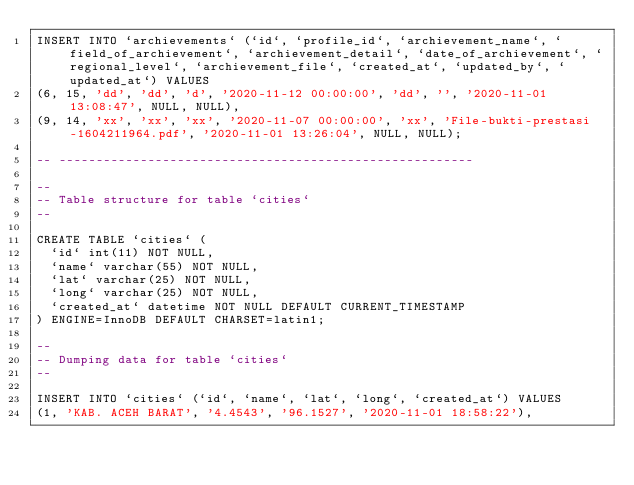Convert code to text. <code><loc_0><loc_0><loc_500><loc_500><_SQL_>INSERT INTO `archievements` (`id`, `profile_id`, `archievement_name`, `field_of_archievement`, `archievement_detail`, `date_of_archievement`, `regional_level`, `archievement_file`, `created_at`, `updated_by`, `updated_at`) VALUES
(6, 15, 'dd', 'dd', 'd', '2020-11-12 00:00:00', 'dd', '', '2020-11-01 13:08:47', NULL, NULL),
(9, 14, 'xx', 'xx', 'xx', '2020-11-07 00:00:00', 'xx', 'File-bukti-prestasi-1604211964.pdf', '2020-11-01 13:26:04', NULL, NULL);

-- --------------------------------------------------------

--
-- Table structure for table `cities`
--

CREATE TABLE `cities` (
  `id` int(11) NOT NULL,
  `name` varchar(55) NOT NULL,
  `lat` varchar(25) NOT NULL,
  `long` varchar(25) NOT NULL,
  `created_at` datetime NOT NULL DEFAULT CURRENT_TIMESTAMP
) ENGINE=InnoDB DEFAULT CHARSET=latin1;

--
-- Dumping data for table `cities`
--

INSERT INTO `cities` (`id`, `name`, `lat`, `long`, `created_at`) VALUES
(1, 'KAB. ACEH BARAT', '4.4543', '96.1527', '2020-11-01 18:58:22'),</code> 